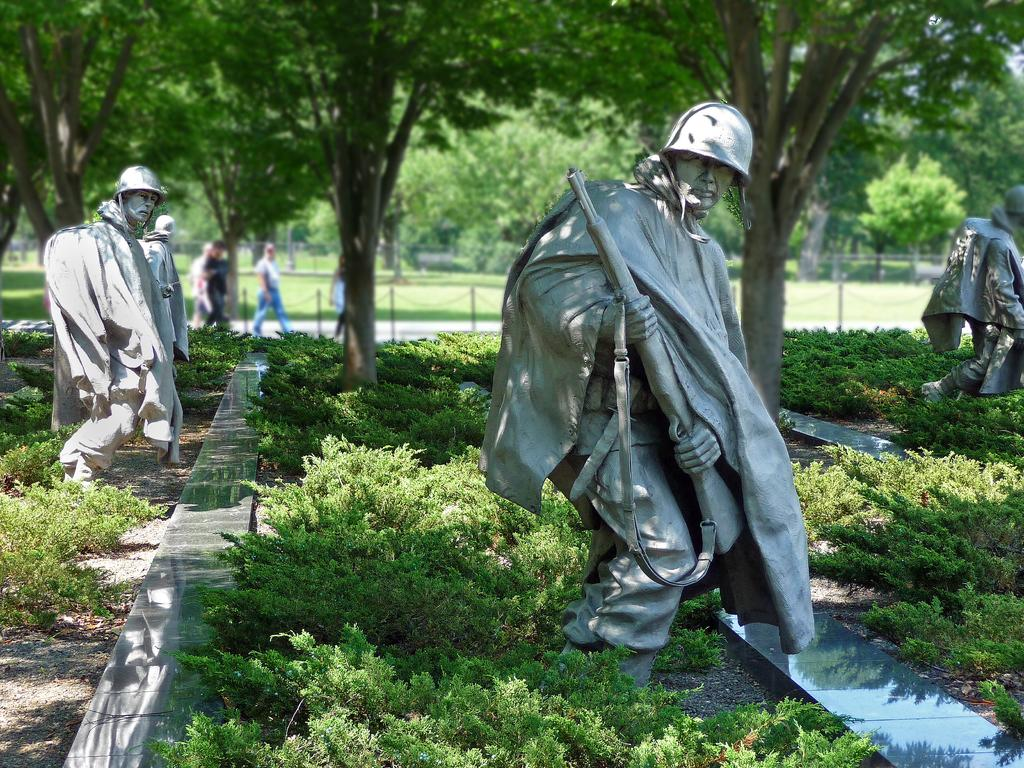What types of living organisms can be seen in the image? Plants can be seen in the image. What other objects are present in the image besides plants? There are statues in the image. What can be seen in the background of the image? There is a group of people and trees in the background of the image. What type of leather is being used to make the finger in the image? There is no leather or finger present in the image. 